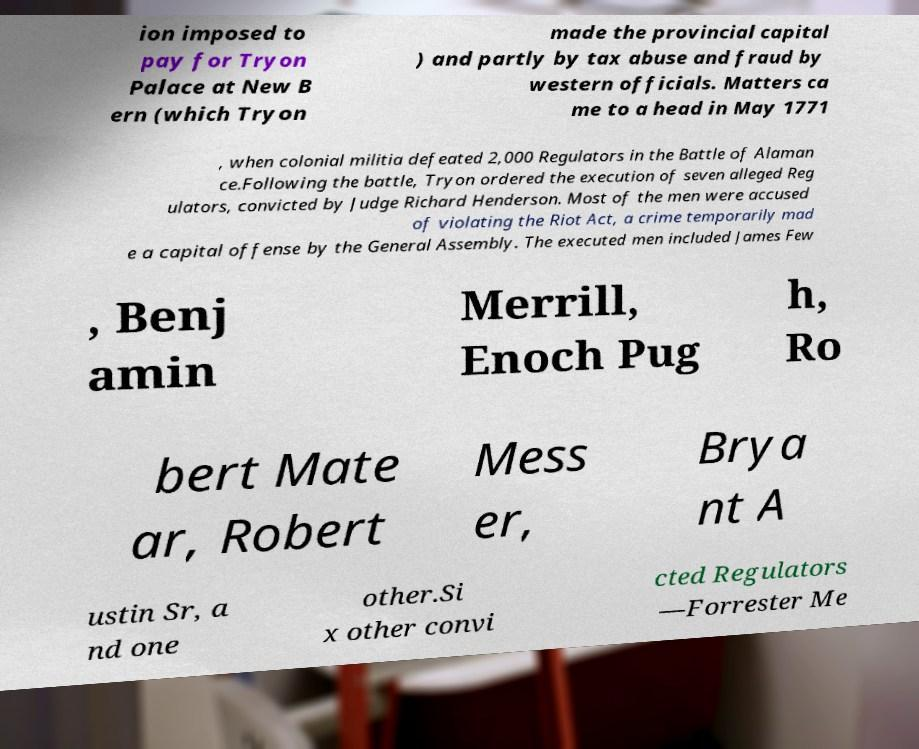Please read and relay the text visible in this image. What does it say? ion imposed to pay for Tryon Palace at New B ern (which Tryon made the provincial capital ) and partly by tax abuse and fraud by western officials. Matters ca me to a head in May 1771 , when colonial militia defeated 2,000 Regulators in the Battle of Alaman ce.Following the battle, Tryon ordered the execution of seven alleged Reg ulators, convicted by Judge Richard Henderson. Most of the men were accused of violating the Riot Act, a crime temporarily mad e a capital offense by the General Assembly. The executed men included James Few , Benj amin Merrill, Enoch Pug h, Ro bert Mate ar, Robert Mess er, Brya nt A ustin Sr, a nd one other.Si x other convi cted Regulators —Forrester Me 